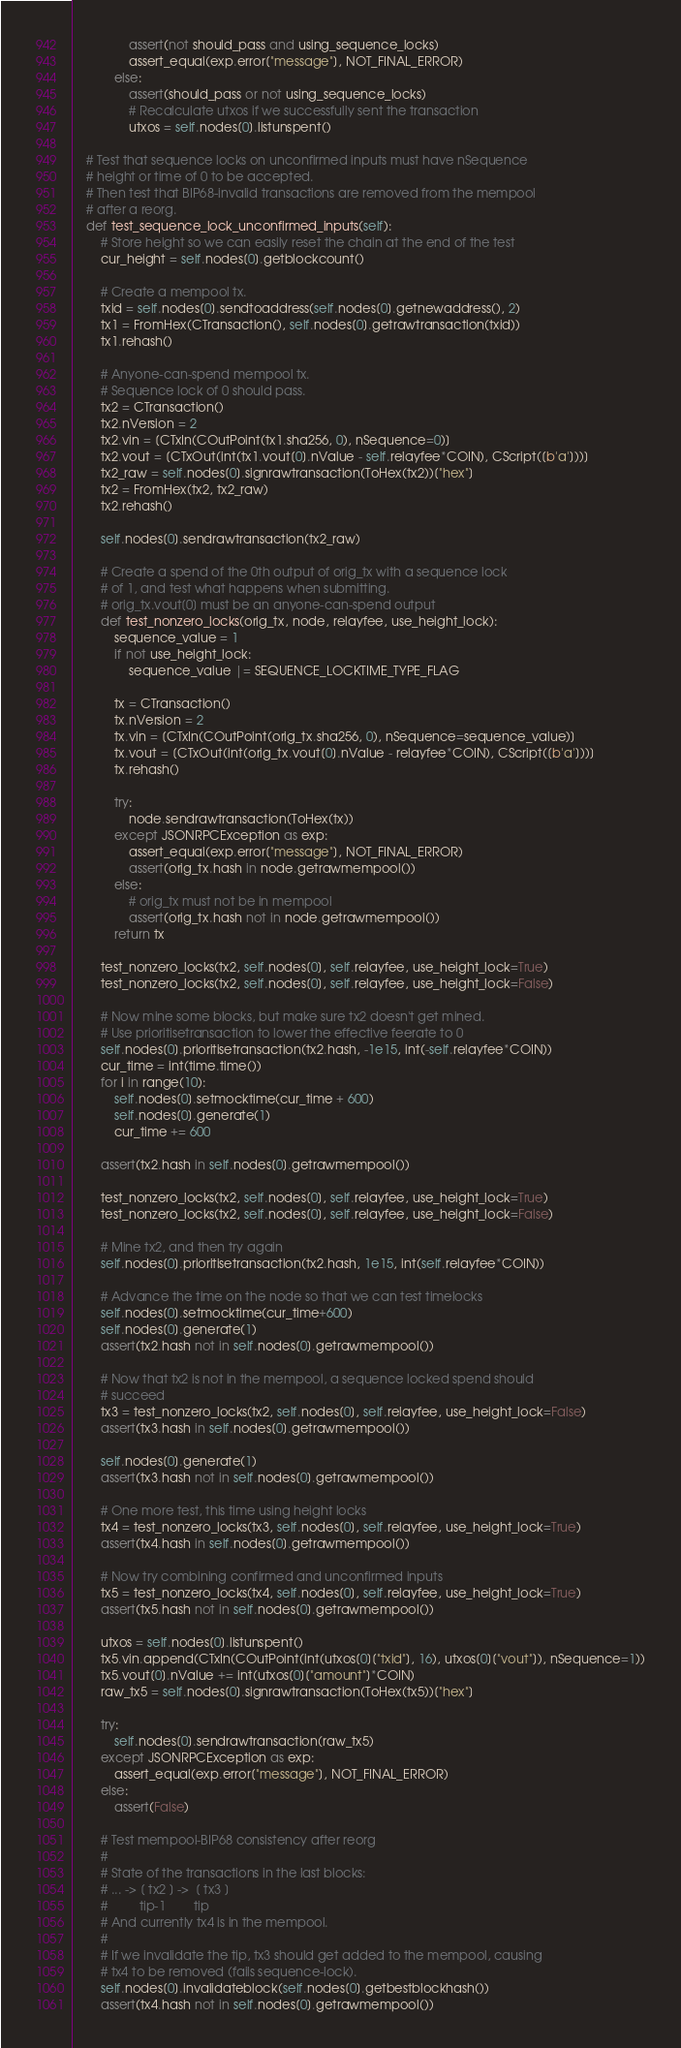Convert code to text. <code><loc_0><loc_0><loc_500><loc_500><_Python_>                assert(not should_pass and using_sequence_locks)
                assert_equal(exp.error["message"], NOT_FINAL_ERROR)
            else:
                assert(should_pass or not using_sequence_locks)
                # Recalculate utxos if we successfully sent the transaction
                utxos = self.nodes[0].listunspent()

    # Test that sequence locks on unconfirmed inputs must have nSequence
    # height or time of 0 to be accepted.
    # Then test that BIP68-invalid transactions are removed from the mempool
    # after a reorg.
    def test_sequence_lock_unconfirmed_inputs(self):
        # Store height so we can easily reset the chain at the end of the test
        cur_height = self.nodes[0].getblockcount()

        # Create a mempool tx.
        txid = self.nodes[0].sendtoaddress(self.nodes[0].getnewaddress(), 2)
        tx1 = FromHex(CTransaction(), self.nodes[0].getrawtransaction(txid))
        tx1.rehash()

        # Anyone-can-spend mempool tx.
        # Sequence lock of 0 should pass.
        tx2 = CTransaction()
        tx2.nVersion = 2
        tx2.vin = [CTxIn(COutPoint(tx1.sha256, 0), nSequence=0)]
        tx2.vout = [CTxOut(int(tx1.vout[0].nValue - self.relayfee*COIN), CScript([b'a']))]
        tx2_raw = self.nodes[0].signrawtransaction(ToHex(tx2))["hex"]
        tx2 = FromHex(tx2, tx2_raw)
        tx2.rehash()

        self.nodes[0].sendrawtransaction(tx2_raw)

        # Create a spend of the 0th output of orig_tx with a sequence lock
        # of 1, and test what happens when submitting.
        # orig_tx.vout[0] must be an anyone-can-spend output
        def test_nonzero_locks(orig_tx, node, relayfee, use_height_lock):
            sequence_value = 1
            if not use_height_lock:
                sequence_value |= SEQUENCE_LOCKTIME_TYPE_FLAG

            tx = CTransaction()
            tx.nVersion = 2
            tx.vin = [CTxIn(COutPoint(orig_tx.sha256, 0), nSequence=sequence_value)]
            tx.vout = [CTxOut(int(orig_tx.vout[0].nValue - relayfee*COIN), CScript([b'a']))]
            tx.rehash()

            try:
                node.sendrawtransaction(ToHex(tx))
            except JSONRPCException as exp:
                assert_equal(exp.error["message"], NOT_FINAL_ERROR)
                assert(orig_tx.hash in node.getrawmempool())
            else:
                # orig_tx must not be in mempool
                assert(orig_tx.hash not in node.getrawmempool())
            return tx

        test_nonzero_locks(tx2, self.nodes[0], self.relayfee, use_height_lock=True)
        test_nonzero_locks(tx2, self.nodes[0], self.relayfee, use_height_lock=False)

        # Now mine some blocks, but make sure tx2 doesn't get mined.
        # Use prioritisetransaction to lower the effective feerate to 0
        self.nodes[0].prioritisetransaction(tx2.hash, -1e15, int(-self.relayfee*COIN))
        cur_time = int(time.time())
        for i in range(10):
            self.nodes[0].setmocktime(cur_time + 600)
            self.nodes[0].generate(1)
            cur_time += 600

        assert(tx2.hash in self.nodes[0].getrawmempool())

        test_nonzero_locks(tx2, self.nodes[0], self.relayfee, use_height_lock=True)
        test_nonzero_locks(tx2, self.nodes[0], self.relayfee, use_height_lock=False)

        # Mine tx2, and then try again
        self.nodes[0].prioritisetransaction(tx2.hash, 1e15, int(self.relayfee*COIN))

        # Advance the time on the node so that we can test timelocks
        self.nodes[0].setmocktime(cur_time+600)
        self.nodes[0].generate(1)
        assert(tx2.hash not in self.nodes[0].getrawmempool())

        # Now that tx2 is not in the mempool, a sequence locked spend should
        # succeed
        tx3 = test_nonzero_locks(tx2, self.nodes[0], self.relayfee, use_height_lock=False)
        assert(tx3.hash in self.nodes[0].getrawmempool())

        self.nodes[0].generate(1)
        assert(tx3.hash not in self.nodes[0].getrawmempool())

        # One more test, this time using height locks
        tx4 = test_nonzero_locks(tx3, self.nodes[0], self.relayfee, use_height_lock=True)
        assert(tx4.hash in self.nodes[0].getrawmempool())

        # Now try combining confirmed and unconfirmed inputs
        tx5 = test_nonzero_locks(tx4, self.nodes[0], self.relayfee, use_height_lock=True)
        assert(tx5.hash not in self.nodes[0].getrawmempool())

        utxos = self.nodes[0].listunspent()
        tx5.vin.append(CTxIn(COutPoint(int(utxos[0]["txid"], 16), utxos[0]["vout"]), nSequence=1))
        tx5.vout[0].nValue += int(utxos[0]["amount"]*COIN)
        raw_tx5 = self.nodes[0].signrawtransaction(ToHex(tx5))["hex"]

        try:
            self.nodes[0].sendrawtransaction(raw_tx5)
        except JSONRPCException as exp:
            assert_equal(exp.error["message"], NOT_FINAL_ERROR)
        else:
            assert(False)

        # Test mempool-BIP68 consistency after reorg
        #
        # State of the transactions in the last blocks:
        # ... -> [ tx2 ] ->  [ tx3 ]
        #         tip-1        tip
        # And currently tx4 is in the mempool.
        #
        # If we invalidate the tip, tx3 should get added to the mempool, causing
        # tx4 to be removed (fails sequence-lock).
        self.nodes[0].invalidateblock(self.nodes[0].getbestblockhash())
        assert(tx4.hash not in self.nodes[0].getrawmempool())</code> 